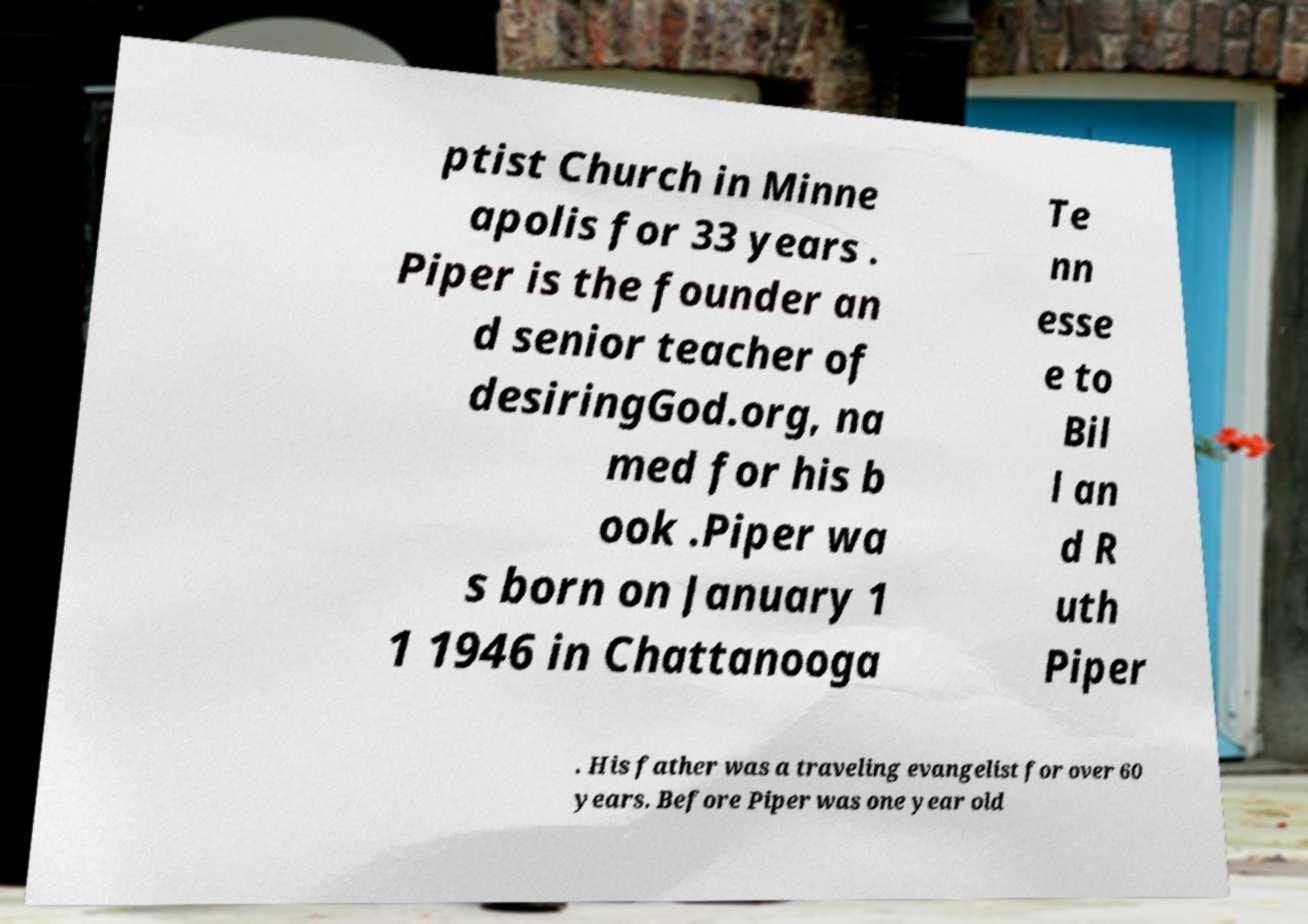For documentation purposes, I need the text within this image transcribed. Could you provide that? ptist Church in Minne apolis for 33 years . Piper is the founder an d senior teacher of desiringGod.org, na med for his b ook .Piper wa s born on January 1 1 1946 in Chattanooga Te nn esse e to Bil l an d R uth Piper . His father was a traveling evangelist for over 60 years. Before Piper was one year old 